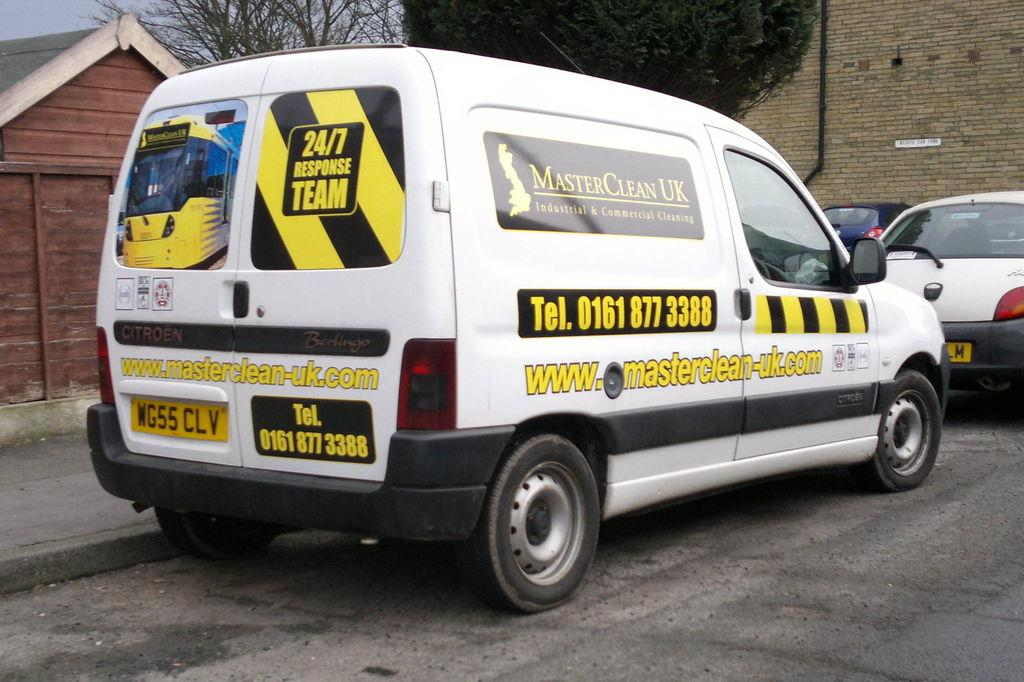<image>
Describe the image concisely. A white van from Master Clean UK is parked behind a white car. 